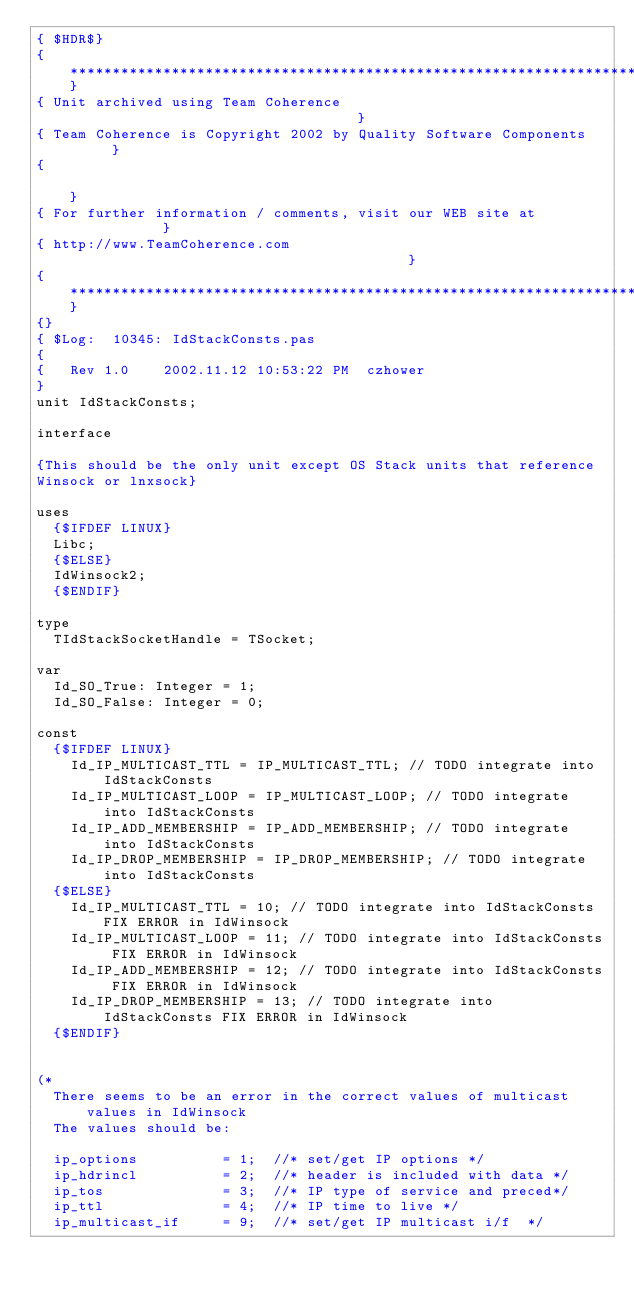Convert code to text. <code><loc_0><loc_0><loc_500><loc_500><_Pascal_>{ $HDR$}
{**********************************************************************}
{ Unit archived using Team Coherence                                   }
{ Team Coherence is Copyright 2002 by Quality Software Components      }
{                                                                      }
{ For further information / comments, visit our WEB site at            }
{ http://www.TeamCoherence.com                                         }
{**********************************************************************}
{}
{ $Log:  10345: IdStackConsts.pas 
{
{   Rev 1.0    2002.11.12 10:53:22 PM  czhower
}
unit IdStackConsts;

interface

{This should be the only unit except OS Stack units that reference
Winsock or lnxsock}

uses
  {$IFDEF LINUX}
  Libc;
  {$ELSE}
  IdWinsock2;
  {$ENDIF}

type
  TIdStackSocketHandle = TSocket;

var
  Id_SO_True: Integer = 1;
  Id_SO_False: Integer = 0;

const
  {$IFDEF LINUX}
    Id_IP_MULTICAST_TTL = IP_MULTICAST_TTL; // TODO integrate into IdStackConsts
    Id_IP_MULTICAST_LOOP = IP_MULTICAST_LOOP; // TODO integrate into IdStackConsts
    Id_IP_ADD_MEMBERSHIP = IP_ADD_MEMBERSHIP; // TODO integrate into IdStackConsts
    Id_IP_DROP_MEMBERSHIP = IP_DROP_MEMBERSHIP; // TODO integrate into IdStackConsts
  {$ELSE}
    Id_IP_MULTICAST_TTL = 10; // TODO integrate into IdStackConsts FIX ERROR in IdWinsock
    Id_IP_MULTICAST_LOOP = 11; // TODO integrate into IdStackConsts FIX ERROR in IdWinsock
    Id_IP_ADD_MEMBERSHIP = 12; // TODO integrate into IdStackConsts FIX ERROR in IdWinsock
    Id_IP_DROP_MEMBERSHIP = 13; // TODO integrate into IdStackConsts FIX ERROR in IdWinsock
  {$ENDIF}
  

(*
  There seems to be an error in the correct values of multicast values in IdWinsock
  The values should be:

  ip_options          = 1;  //* set/get IP options */
  ip_hdrincl          = 2;  //* header is included with data */
  ip_tos              = 3;  //* IP type of service and preced*/
  ip_ttl              = 4;  //* IP time to live */
  ip_multicast_if     = 9;  //* set/get IP multicast i/f  */</code> 